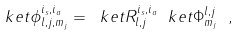Convert formula to latex. <formula><loc_0><loc_0><loc_500><loc_500>\ k e t { \phi ^ { i _ { s } , i _ { a } } _ { l , j , m _ { j } } } = \ k e t { R ^ { i _ { s } , i _ { a } } _ { l , j } } \ k e t { \Phi ^ { l , j } _ { m _ { j } } } \ ,</formula> 